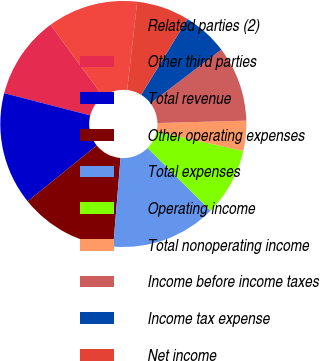<chart> <loc_0><loc_0><loc_500><loc_500><pie_chart><fcel>Related parties (2)<fcel>Other third parties<fcel>Total revenue<fcel>Other operating expenses<fcel>Total expenses<fcel>Operating income<fcel>Total nonoperating income<fcel>Income before income taxes<fcel>Income tax expense<fcel>Net income<nl><fcel>11.88%<fcel>10.89%<fcel>14.85%<fcel>12.87%<fcel>13.86%<fcel>8.91%<fcel>3.96%<fcel>9.9%<fcel>5.94%<fcel>6.93%<nl></chart> 